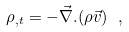Convert formula to latex. <formula><loc_0><loc_0><loc_500><loc_500>\rho _ { , t } = - \vec { \nabla } . ( \rho \vec { v } ) \ ,</formula> 